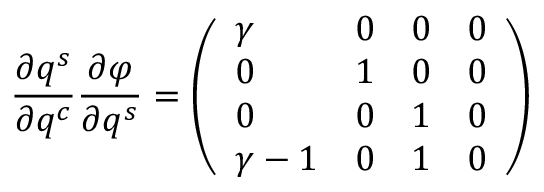Convert formula to latex. <formula><loc_0><loc_0><loc_500><loc_500>\frac { \partial q ^ { s } } { \partial q ^ { c } } \frac { \partial \varphi } { \partial q ^ { s } } = \left ( \begin{array} { l l l l } { \gamma } & { 0 } & { 0 } & { 0 } \\ { 0 } & { 1 } & { 0 } & { 0 } \\ { 0 } & { 0 } & { 1 } & { 0 } \\ { \gamma - 1 } & { 0 } & { 1 } & { 0 } \end{array} \right )</formula> 